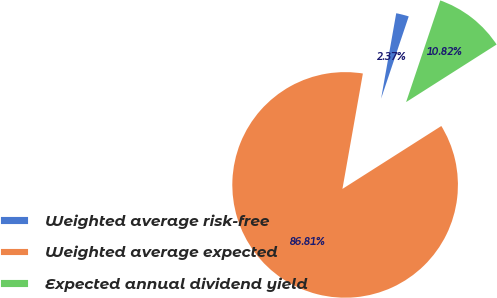<chart> <loc_0><loc_0><loc_500><loc_500><pie_chart><fcel>Weighted average risk-free<fcel>Weighted average expected<fcel>Expected annual dividend yield<nl><fcel>2.37%<fcel>86.81%<fcel>10.82%<nl></chart> 